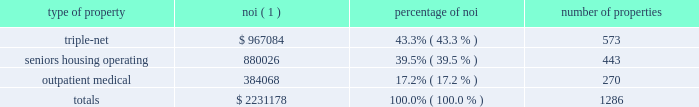Item 7 .
Management 2019s discussion and analysis of financial condition and results of operations the following discussion and analysis is based primarily on the consolidated financial statements of welltower inc .
Presented in conformity with u.s .
Generally accepted accounting principles ( 201cu.s .
Gaap 201d ) for the periods presented and should be read together with the notes thereto contained in this annual report on form 10-k .
Other important factors are identified in 201citem 1 2014 business 201d and 201citem 1a 2014 risk factors 201d above .
Executive summary company overview welltower inc .
( nyse:well ) , an s&p 500 company headquartered in toledo , ohio , is driving the transformation of health care infrastructure .
The company invests with leading seniors housing operators , post- acute providers and health systems to fund the real estate and infrastructure needed to scale innovative care delivery models and improve people 2019s wellness and overall health care experience .
Welltowertm , a real estate investment trust ( 201creit 201d ) , owns interests in properties concentrated in major , high-growth markets in the united states ( 201cu.s . 201d ) , canada and the united kingdom ( 201cu.k . 201d ) , consisting of seniors housing and post-acute communities and outpatient medical properties .
Our capital programs , when combined with comprehensive planning , development and property management services , make us a single-source solution for acquiring , planning , developing , managing , repositioning and monetizing real estate assets .
The table summarizes our consolidated portfolio for the year ended december 31 , 2017 ( dollars in thousands ) : type of property noi ( 1 ) percentage of number of properties .
( 1 ) represents consolidated noi and excludes our share of investments in unconsolidated entities .
Entities in which we have a joint venture with a minority partner are shown at 100% ( 100 % ) of the joint venture amount .
See non-gaap financial measures for additional information and reconciliation .
Business strategy our primary objectives are to protect stockholder capital and enhance stockholder value .
We seek to pay consistent cash dividends to stockholders and create opportunities to increase dividend payments to stockholders as a result of annual increases in net operating income and portfolio growth .
To meet these objectives , we invest across the full spectrum of seniors housing and health care real estate and diversify our investment portfolio by property type , relationship and geographic location .
Substantially all of our revenues are derived from operating lease rentals , resident fees/services , and interest earned on outstanding loans receivable .
These items represent our primary sources of liquidity to fund distributions and depend upon the continued ability of our obligors to make contractual rent and interest payments to us and the profitability of our operating properties .
To the extent that our obligors/partners experience operating difficulties and become unable to generate sufficient cash to make payments or operating distributions to us , there could be a material adverse impact on our consolidated results of operations , liquidity and/or financial condition .
To mitigate this risk , we monitor our investments through a variety of methods determined by the type of property .
Our asset management process for seniors housing properties generally includes review of monthly financial statements and other operating data for each property , review of obligor/ partner creditworthiness , property inspections , and review of covenant compliance relating to licensure , real estate taxes , letters of credit and other collateral .
Our internal property management division manages and monitors the outpatient medical portfolio with a comprehensive process including review of tenant relations .
What portion of the total number of properties is related to triple-net? 
Computations: (573 / 1286)
Answer: 0.44557. 